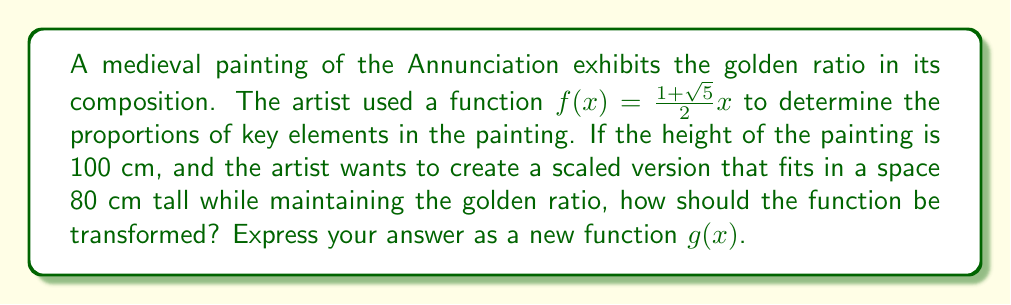What is the answer to this math problem? To solve this problem, we need to follow these steps:

1) First, let's recall that the golden ratio is represented by $\phi = \frac{1+\sqrt{5}}{2} \approx 1.618$.

2) The original function $f(x) = \frac{1+\sqrt{5}}{2}x$ represents the golden ratio scaling in the original painting.

3) To fit the painting into a smaller space while maintaining the same proportions, we need to scale the function. The scaling factor can be determined by the ratio of the new height to the original height:

   Scaling factor = $\frac{\text{New Height}}{\text{Original Height}} = \frac{80}{100} = 0.8$

4) To scale a function, we multiply it by the scaling factor. So our new function will be:

   $g(x) = 0.8 \cdot f(x)$

5) Substituting the original function:

   $g(x) = 0.8 \cdot (\frac{1+\sqrt{5}}{2}x)$

6) Simplifying:

   $g(x) = 0.8 \cdot \frac{1+\sqrt{5}}{2}x = \frac{0.8(1+\sqrt{5})}{2}x$

Therefore, the new function $g(x)$ represents a scaled version of the original function that maintains the golden ratio proportions while fitting in the smaller space.
Answer: $g(x) = \frac{0.8(1+\sqrt{5})}{2}x$ 